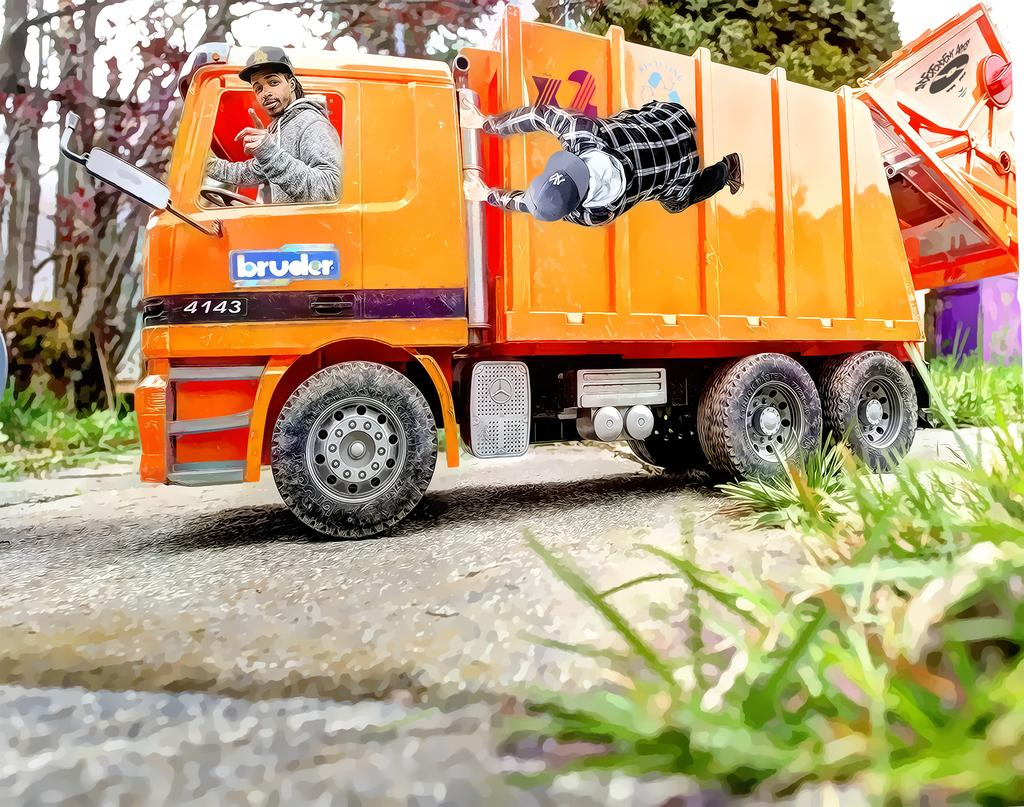What is the main object in the image? There is a vehicle in the image. What type of natural elements can be seen in the image? There are trees and plants in the image. Are there any people present in the image? Yes, there are persons in the image. How does the image appear in terms of its visual style? The image has a photo effect. What type of bucket is being used by the persons in the image? There is no bucket present in the image. What kind of club activity is taking place in the image? There is no club activity or club-related objects present in the image. 